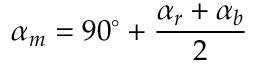<formula> <loc_0><loc_0><loc_500><loc_500>\alpha _ { m } = 9 0 ^ { \circ } + { \frac { \alpha _ { r } + \alpha _ { b } } { 2 } }</formula> 